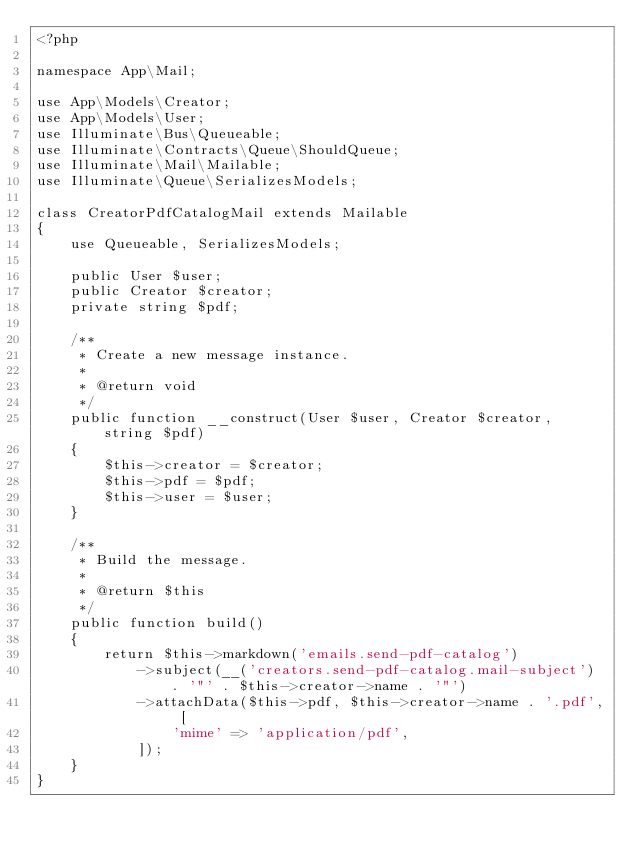Convert code to text. <code><loc_0><loc_0><loc_500><loc_500><_PHP_><?php

namespace App\Mail;

use App\Models\Creator;
use App\Models\User;
use Illuminate\Bus\Queueable;
use Illuminate\Contracts\Queue\ShouldQueue;
use Illuminate\Mail\Mailable;
use Illuminate\Queue\SerializesModels;

class CreatorPdfCatalogMail extends Mailable
{
    use Queueable, SerializesModels;

    public User $user;
    public Creator $creator;
    private string $pdf;

    /**
     * Create a new message instance.
     *
     * @return void
     */
    public function __construct(User $user, Creator $creator, string $pdf)
    {
        $this->creator = $creator;
        $this->pdf = $pdf;
        $this->user = $user;
    }

    /**
     * Build the message.
     *
     * @return $this
     */
    public function build()
    {
        return $this->markdown('emails.send-pdf-catalog')
            ->subject(__('creators.send-pdf-catalog.mail-subject') . '"' . $this->creator->name . '"')
            ->attachData($this->pdf, $this->creator->name . '.pdf', [
                'mime' => 'application/pdf',
            ]);
    }
}
</code> 